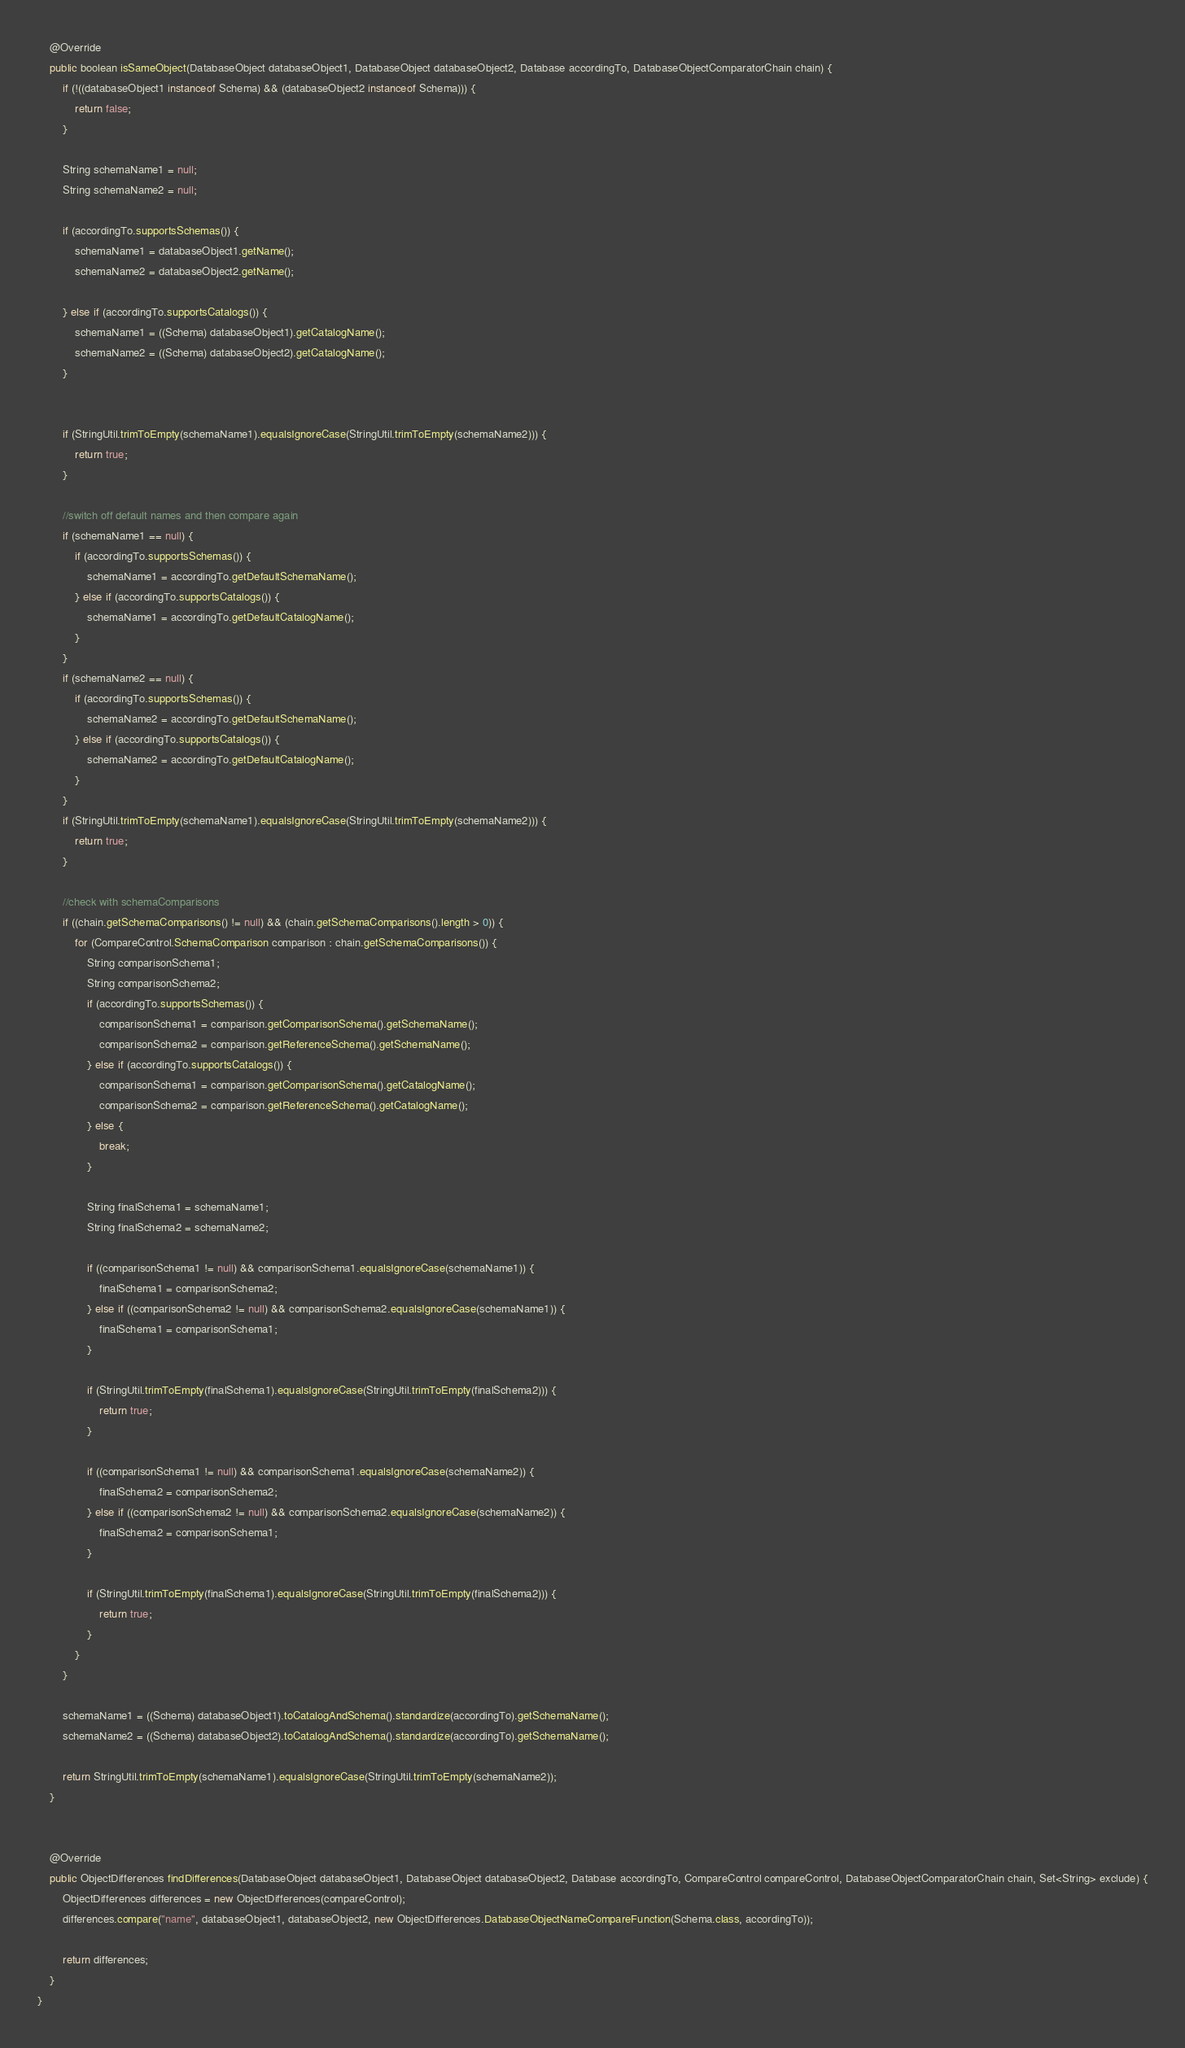<code> <loc_0><loc_0><loc_500><loc_500><_Java_>    @Override
    public boolean isSameObject(DatabaseObject databaseObject1, DatabaseObject databaseObject2, Database accordingTo, DatabaseObjectComparatorChain chain) {
        if (!((databaseObject1 instanceof Schema) && (databaseObject2 instanceof Schema))) {
            return false;
        }

        String schemaName1 = null;
        String schemaName2 = null;

        if (accordingTo.supportsSchemas()) {
            schemaName1 = databaseObject1.getName();
            schemaName2 = databaseObject2.getName();

        } else if (accordingTo.supportsCatalogs()) {
            schemaName1 = ((Schema) databaseObject1).getCatalogName();
            schemaName2 = ((Schema) databaseObject2).getCatalogName();
        }


        if (StringUtil.trimToEmpty(schemaName1).equalsIgnoreCase(StringUtil.trimToEmpty(schemaName2))) {
            return true;
        }

        //switch off default names and then compare again
        if (schemaName1 == null) {
            if (accordingTo.supportsSchemas()) {
                schemaName1 = accordingTo.getDefaultSchemaName();
            } else if (accordingTo.supportsCatalogs()) {
                schemaName1 = accordingTo.getDefaultCatalogName();
            }
        }
        if (schemaName2 == null) {
            if (accordingTo.supportsSchemas()) {
                schemaName2 = accordingTo.getDefaultSchemaName();
            } else if (accordingTo.supportsCatalogs()) {
                schemaName2 = accordingTo.getDefaultCatalogName();
            }
        }
        if (StringUtil.trimToEmpty(schemaName1).equalsIgnoreCase(StringUtil.trimToEmpty(schemaName2))) {
            return true;
        }

        //check with schemaComparisons
        if ((chain.getSchemaComparisons() != null) && (chain.getSchemaComparisons().length > 0)) {
            for (CompareControl.SchemaComparison comparison : chain.getSchemaComparisons()) {
                String comparisonSchema1;
                String comparisonSchema2;
                if (accordingTo.supportsSchemas()) {
                    comparisonSchema1 = comparison.getComparisonSchema().getSchemaName();
                    comparisonSchema2 = comparison.getReferenceSchema().getSchemaName();
                } else if (accordingTo.supportsCatalogs()) {
                    comparisonSchema1 = comparison.getComparisonSchema().getCatalogName();
                    comparisonSchema2 = comparison.getReferenceSchema().getCatalogName();
                } else {
                    break;
                }

                String finalSchema1 = schemaName1;
                String finalSchema2 = schemaName2;

                if ((comparisonSchema1 != null) && comparisonSchema1.equalsIgnoreCase(schemaName1)) {
                    finalSchema1 = comparisonSchema2;
                } else if ((comparisonSchema2 != null) && comparisonSchema2.equalsIgnoreCase(schemaName1)) {
                    finalSchema1 = comparisonSchema1;
                }

                if (StringUtil.trimToEmpty(finalSchema1).equalsIgnoreCase(StringUtil.trimToEmpty(finalSchema2))) {
                    return true;
                }

                if ((comparisonSchema1 != null) && comparisonSchema1.equalsIgnoreCase(schemaName2)) {
                    finalSchema2 = comparisonSchema2;
                } else if ((comparisonSchema2 != null) && comparisonSchema2.equalsIgnoreCase(schemaName2)) {
                    finalSchema2 = comparisonSchema1;
                }

                if (StringUtil.trimToEmpty(finalSchema1).equalsIgnoreCase(StringUtil.trimToEmpty(finalSchema2))) {
                    return true;
                }
            }
        }

        schemaName1 = ((Schema) databaseObject1).toCatalogAndSchema().standardize(accordingTo).getSchemaName();
        schemaName2 = ((Schema) databaseObject2).toCatalogAndSchema().standardize(accordingTo).getSchemaName();

        return StringUtil.trimToEmpty(schemaName1).equalsIgnoreCase(StringUtil.trimToEmpty(schemaName2));
    }


    @Override
    public ObjectDifferences findDifferences(DatabaseObject databaseObject1, DatabaseObject databaseObject2, Database accordingTo, CompareControl compareControl, DatabaseObjectComparatorChain chain, Set<String> exclude) {
        ObjectDifferences differences = new ObjectDifferences(compareControl);
        differences.compare("name", databaseObject1, databaseObject2, new ObjectDifferences.DatabaseObjectNameCompareFunction(Schema.class, accordingTo));

        return differences;
    }
}
</code> 